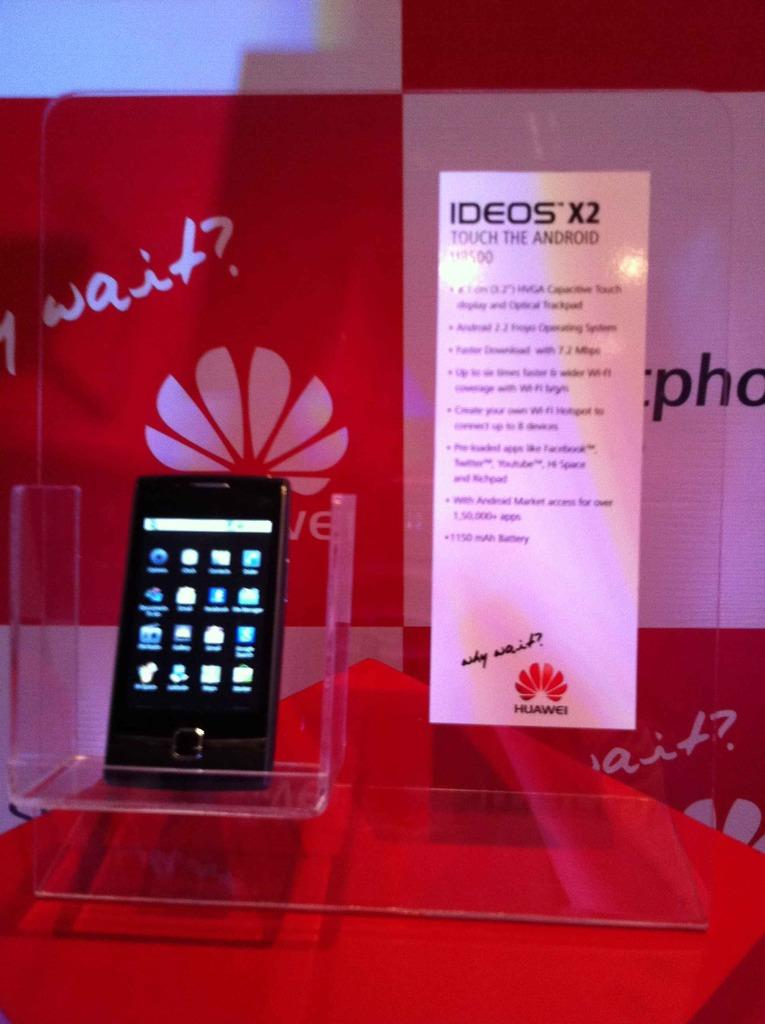<image>
Offer a succinct explanation of the picture presented. A display with a black phone called the Ideos X2. 